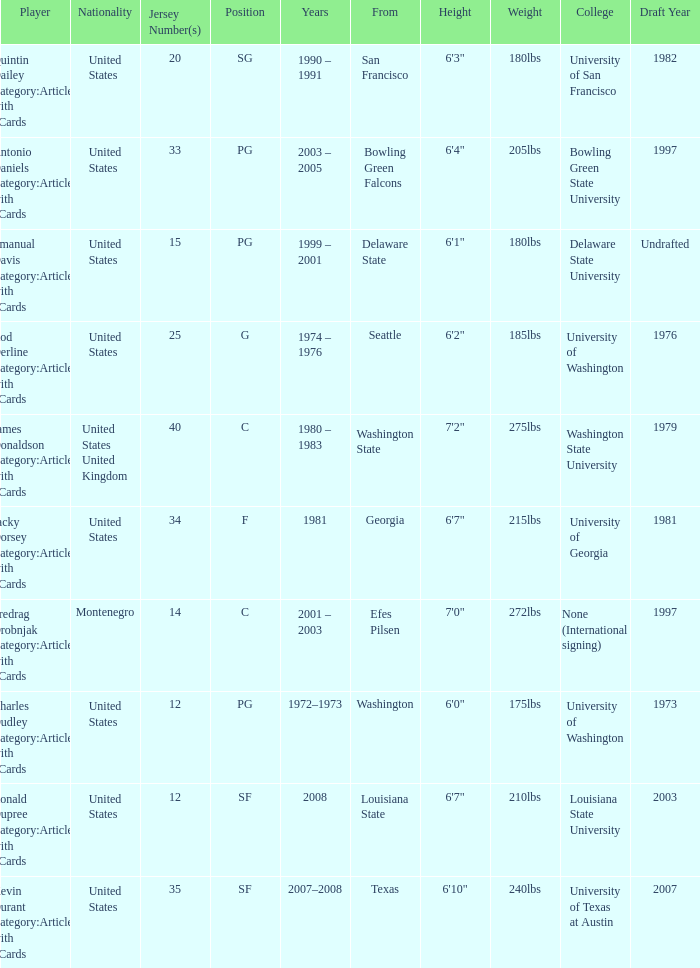What is the lowest jersey number of a player from louisiana state? 12.0. 